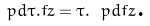<formula> <loc_0><loc_0><loc_500><loc_500>\ p d { \tau . f } { z } = \tau . \ p d { f } { z } \text {.}</formula> 